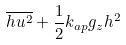<formula> <loc_0><loc_0><loc_500><loc_500>\overline { h u ^ { 2 } } + \frac { 1 } { 2 } k _ { a p } g _ { z } h ^ { 2 }</formula> 